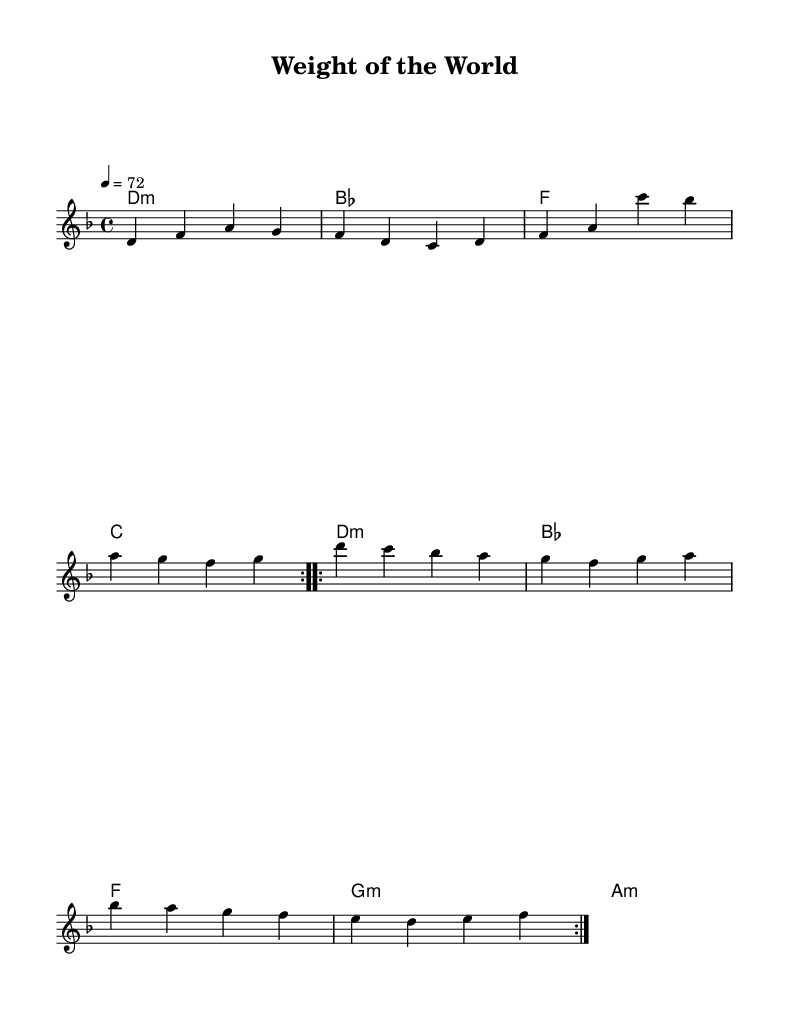What is the key signature of this music? The key signature is D minor, which has one flat (B flat).
Answer: D minor What is the time signature of this music? The time signature is 4/4, indicating four beats per measure.
Answer: 4/4 What is the tempo marking for this piece? The tempo marking is 4 equals 72, meaning there are 72 quarter note beats per minute.
Answer: 72 How many times is the first section repeated? The first section is repeated twice, indicated by the "volta" markings.
Answer: 2 What is the last chord of the song? The last chord of the song is A minor, which is the final chord in the chord progression.
Answer: A minor Which type of songs does this piece belong to? This piece is categorized as an introspective pop song, aligning with themes of emotional exploration in social services.
Answer: Introspective pop 